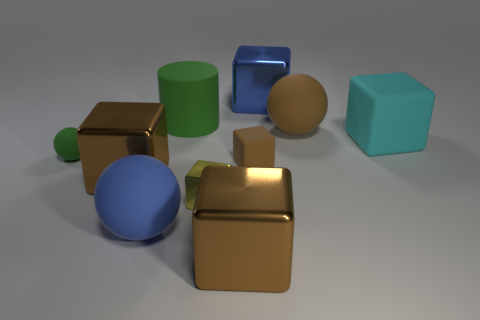Is the large cylinder the same color as the tiny rubber sphere?
Give a very brief answer. Yes. Is there a large cylinder that is right of the yellow object that is to the left of the large matte cube?
Make the answer very short. No. Is the number of big green rubber objects in front of the big cyan matte object the same as the number of big objects?
Give a very brief answer. No. What number of big green cylinders are on the right side of the cyan block that is right of the brown metal cube behind the small yellow metal block?
Make the answer very short. 0. Are there any other rubber cubes of the same size as the yellow cube?
Ensure brevity in your answer.  Yes. Are there fewer brown metallic objects behind the large cyan matte thing than big blue spheres?
Your answer should be very brief. Yes. What material is the small block to the right of the brown shiny cube in front of the big rubber ball in front of the cyan object?
Make the answer very short. Rubber. Are there more rubber things that are in front of the small rubber ball than big matte cylinders in front of the small brown matte object?
Your response must be concise. Yes. How many rubber objects are small yellow cubes or yellow cylinders?
Make the answer very short. 0. There is a large rubber thing that is the same color as the small rubber cube; what shape is it?
Offer a very short reply. Sphere. 